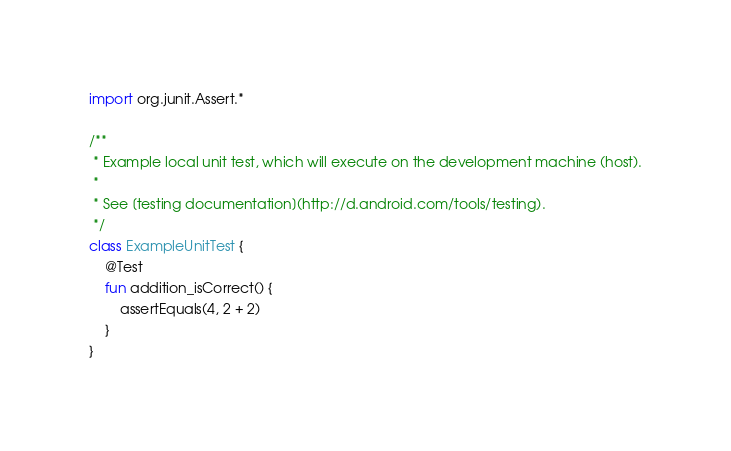<code> <loc_0><loc_0><loc_500><loc_500><_Kotlin_>import org.junit.Assert.*

/**
 * Example local unit test, which will execute on the development machine (host).
 *
 * See [testing documentation](http://d.android.com/tools/testing).
 */
class ExampleUnitTest {
    @Test
    fun addition_isCorrect() {
        assertEquals(4, 2 + 2)
    }
}
</code> 